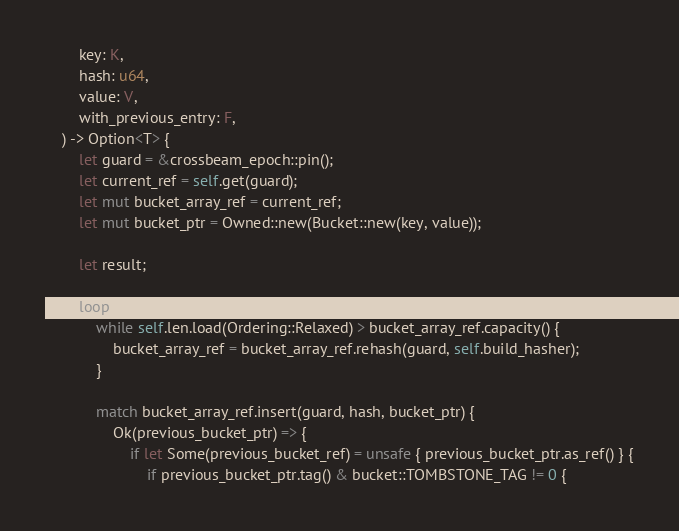Convert code to text. <code><loc_0><loc_0><loc_500><loc_500><_Rust_>        key: K,
        hash: u64,
        value: V,
        with_previous_entry: F,
    ) -> Option<T> {
        let guard = &crossbeam_epoch::pin();
        let current_ref = self.get(guard);
        let mut bucket_array_ref = current_ref;
        let mut bucket_ptr = Owned::new(Bucket::new(key, value));

        let result;

        loop {
            while self.len.load(Ordering::Relaxed) > bucket_array_ref.capacity() {
                bucket_array_ref = bucket_array_ref.rehash(guard, self.build_hasher);
            }

            match bucket_array_ref.insert(guard, hash, bucket_ptr) {
                Ok(previous_bucket_ptr) => {
                    if let Some(previous_bucket_ref) = unsafe { previous_bucket_ptr.as_ref() } {
                        if previous_bucket_ptr.tag() & bucket::TOMBSTONE_TAG != 0 {</code> 